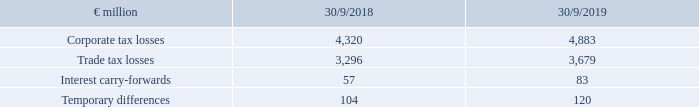No deferred tax assets were capitalised for the following tax loss carry-forwards and interest carry-forwards or temporary differences because realisation of the assets in the short-to-medium term is not expected:
The loss carry-forwards as of the closing date predominantly concern the German consolidation group. They can be carried forward without limitation.
Why were no deferred tax assets capitalised for the following tax loss carry-forwards and interest carry-forwards or temporary differences? Because realisation of the assets in the short-to-medium term is not expected. What do the loss carry-forwards as of the closing date predominantly concern? The german consolidation group. they can be carried forward without limitation. What are the components in the table whereby no deferred tax assets were capitalised? Corporate tax losses, trade tax losses, interest carry-forwards, temporary differences. In which year were the temporary differences larger? 120>104
Answer: 2019. What was the change in interest carry-forwards in FY2019 from FY2018?
Answer scale should be: million. 83-57
Answer: 26. What was the percentage change in interest carry-forwards in FY2019 from FY2018?
Answer scale should be: percent. (83-57)/57
Answer: 45.61. 